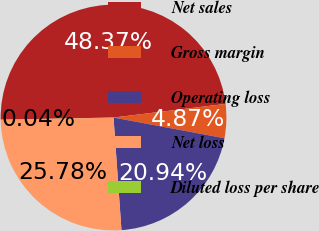Convert chart to OTSL. <chart><loc_0><loc_0><loc_500><loc_500><pie_chart><fcel>Net sales<fcel>Gross margin<fcel>Operating loss<fcel>Net loss<fcel>Diluted loss per share<nl><fcel>48.37%<fcel>4.87%<fcel>20.94%<fcel>25.78%<fcel>0.04%<nl></chart> 